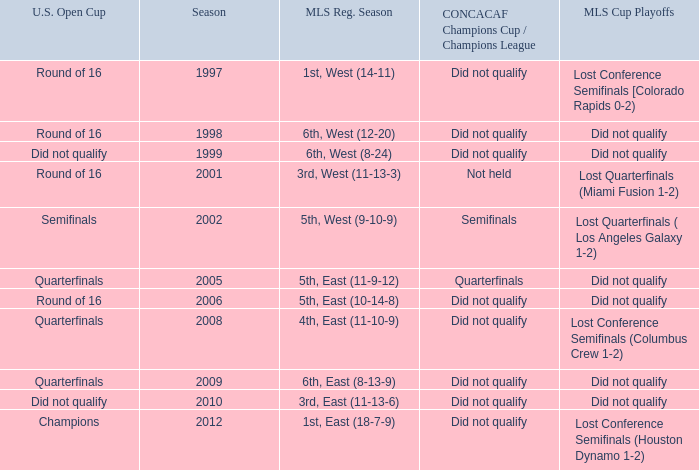What were the placements of the team in regular season when they reached quarterfinals in the U.S. Open Cup but did not qualify for the Concaf Champions Cup? 4th, East (11-10-9), 6th, East (8-13-9). 